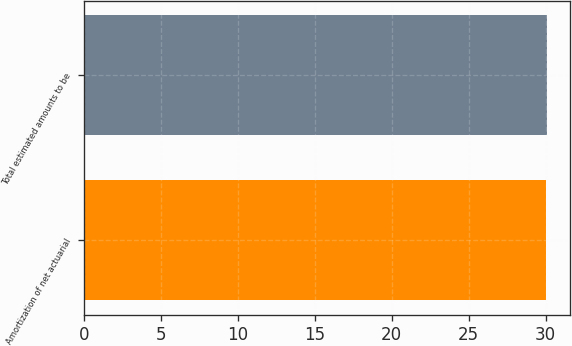<chart> <loc_0><loc_0><loc_500><loc_500><bar_chart><fcel>Amortization of net actuarial<fcel>Total estimated amounts to be<nl><fcel>30<fcel>30.1<nl></chart> 